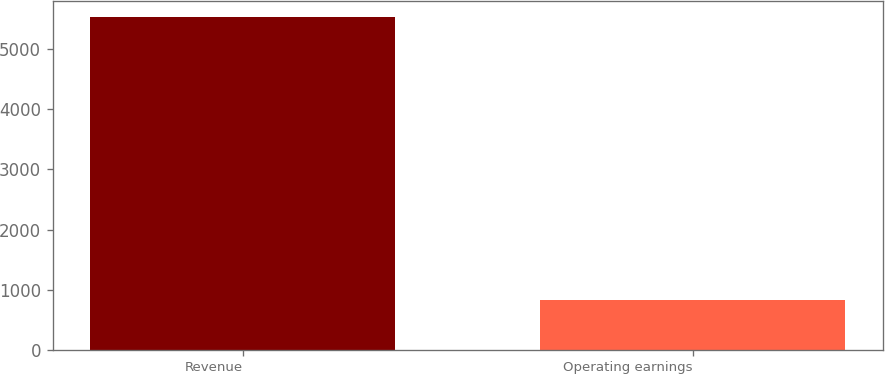Convert chart to OTSL. <chart><loc_0><loc_0><loc_500><loc_500><bar_chart><fcel>Revenue<fcel>Operating earnings<nl><fcel>5530<fcel>831<nl></chart> 